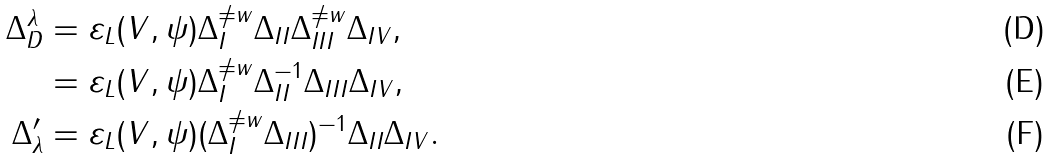<formula> <loc_0><loc_0><loc_500><loc_500>\Delta _ { D } ^ { \lambda } & = \varepsilon _ { L } ( V , \psi ) \Delta _ { I } ^ { \ne w } \Delta _ { I I } \Delta _ { I I I } ^ { \ne w } \Delta _ { I V } , \\ & = \varepsilon _ { L } ( V , \psi ) \Delta _ { I } ^ { \ne w } \Delta _ { I I } ^ { - 1 } \Delta _ { I I I } \Delta _ { I V } , \\ \Delta ^ { \prime } _ { \lambda } & = \varepsilon _ { L } ( V , \psi ) ( \Delta _ { I } ^ { \ne w } \Delta _ { I I I } ) ^ { - 1 } \Delta _ { I I } \Delta _ { I V } .</formula> 